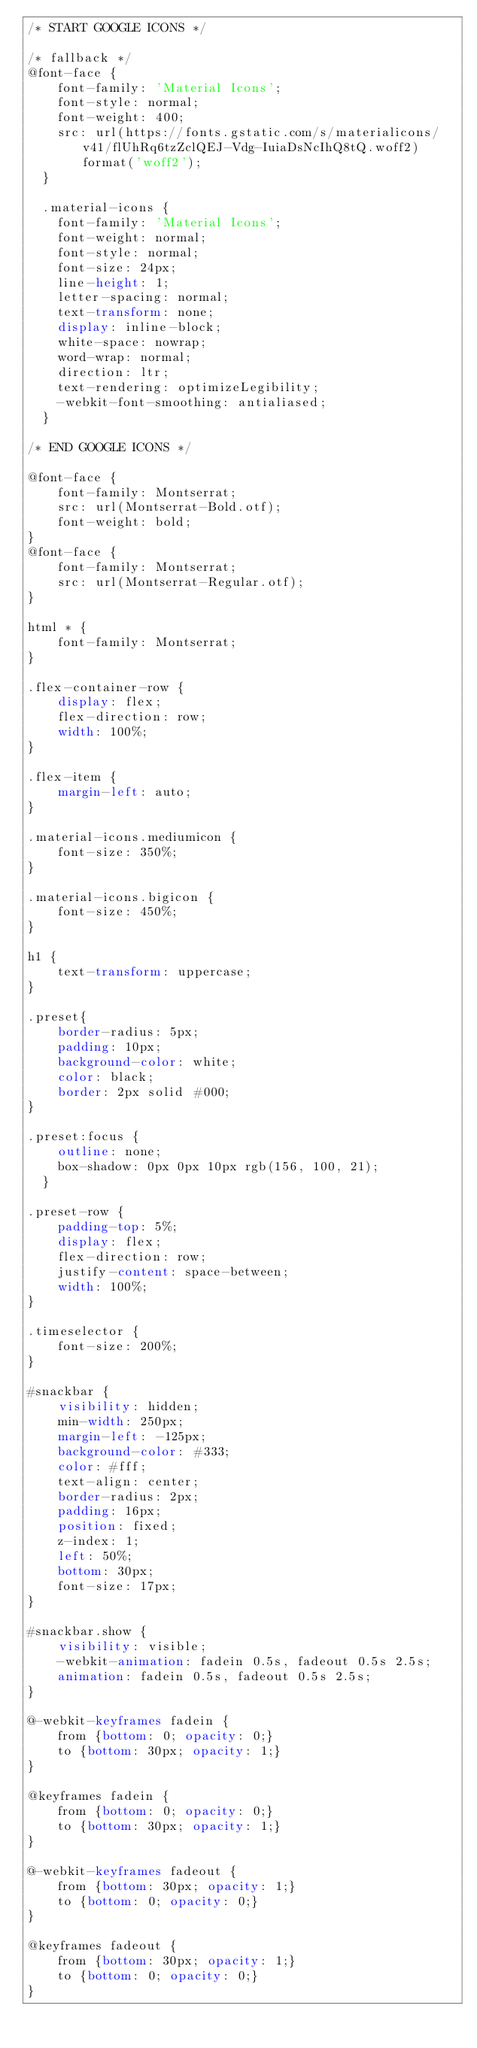<code> <loc_0><loc_0><loc_500><loc_500><_CSS_>/* START GOOGLE ICONS */

/* fallback */
@font-face {
    font-family: 'Material Icons';
    font-style: normal;
    font-weight: 400;
    src: url(https://fonts.gstatic.com/s/materialicons/v41/flUhRq6tzZclQEJ-Vdg-IuiaDsNcIhQ8tQ.woff2) format('woff2');
  }
  
  .material-icons {
    font-family: 'Material Icons';
    font-weight: normal;
    font-style: normal;
    font-size: 24px;
    line-height: 1;
    letter-spacing: normal;
    text-transform: none;
    display: inline-block;
    white-space: nowrap;
    word-wrap: normal;
    direction: ltr;
    text-rendering: optimizeLegibility;
    -webkit-font-smoothing: antialiased;
  }

/* END GOOGLE ICONS */

@font-face {
    font-family: Montserrat;
    src: url(Montserrat-Bold.otf);
    font-weight: bold;
}
@font-face {
    font-family: Montserrat;
    src: url(Montserrat-Regular.otf);
}

html * {
    font-family: Montserrat;
}

.flex-container-row {
    display: flex;
    flex-direction: row;
    width: 100%;
}

.flex-item {
    margin-left: auto;
}

.material-icons.mediumicon {
    font-size: 350%;
}

.material-icons.bigicon {
    font-size: 450%;
}

h1 {
    text-transform: uppercase;
}

.preset{
    border-radius: 5px;
    padding: 10px;
    background-color: white; 
    color: black; 
    border: 2px solid #000;
}

.preset:focus {
    outline: none;
    box-shadow: 0px 0px 10px rgb(156, 100, 21);
  }

.preset-row {
    padding-top: 5%;
    display: flex;
    flex-direction: row;
    justify-content: space-between;
    width: 100%;
}

.timeselector {
    font-size: 200%;
}

#snackbar {
    visibility: hidden;
    min-width: 250px;
    margin-left: -125px;
    background-color: #333;
    color: #fff;
    text-align: center;
    border-radius: 2px;
    padding: 16px;
    position: fixed;
    z-index: 1;
    left: 50%;
    bottom: 30px;
    font-size: 17px;
}

#snackbar.show {
    visibility: visible;
    -webkit-animation: fadein 0.5s, fadeout 0.5s 2.5s;
    animation: fadein 0.5s, fadeout 0.5s 2.5s;
}

@-webkit-keyframes fadein {
    from {bottom: 0; opacity: 0;} 
    to {bottom: 30px; opacity: 1;}
}

@keyframes fadein {
    from {bottom: 0; opacity: 0;}
    to {bottom: 30px; opacity: 1;}
}

@-webkit-keyframes fadeout {
    from {bottom: 30px; opacity: 1;} 
    to {bottom: 0; opacity: 0;}
}

@keyframes fadeout {
    from {bottom: 30px; opacity: 1;}
    to {bottom: 0; opacity: 0;}
}
</code> 